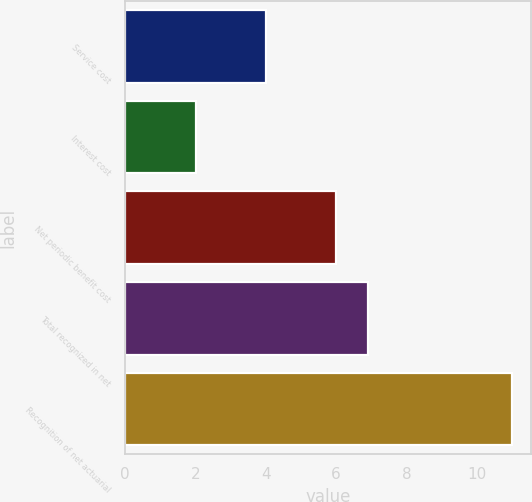Convert chart to OTSL. <chart><loc_0><loc_0><loc_500><loc_500><bar_chart><fcel>Service cost<fcel>Interest cost<fcel>Net periodic benefit cost<fcel>Total recognized in net<fcel>Recognition of net actuarial<nl><fcel>4<fcel>2<fcel>6<fcel>6.9<fcel>11<nl></chart> 